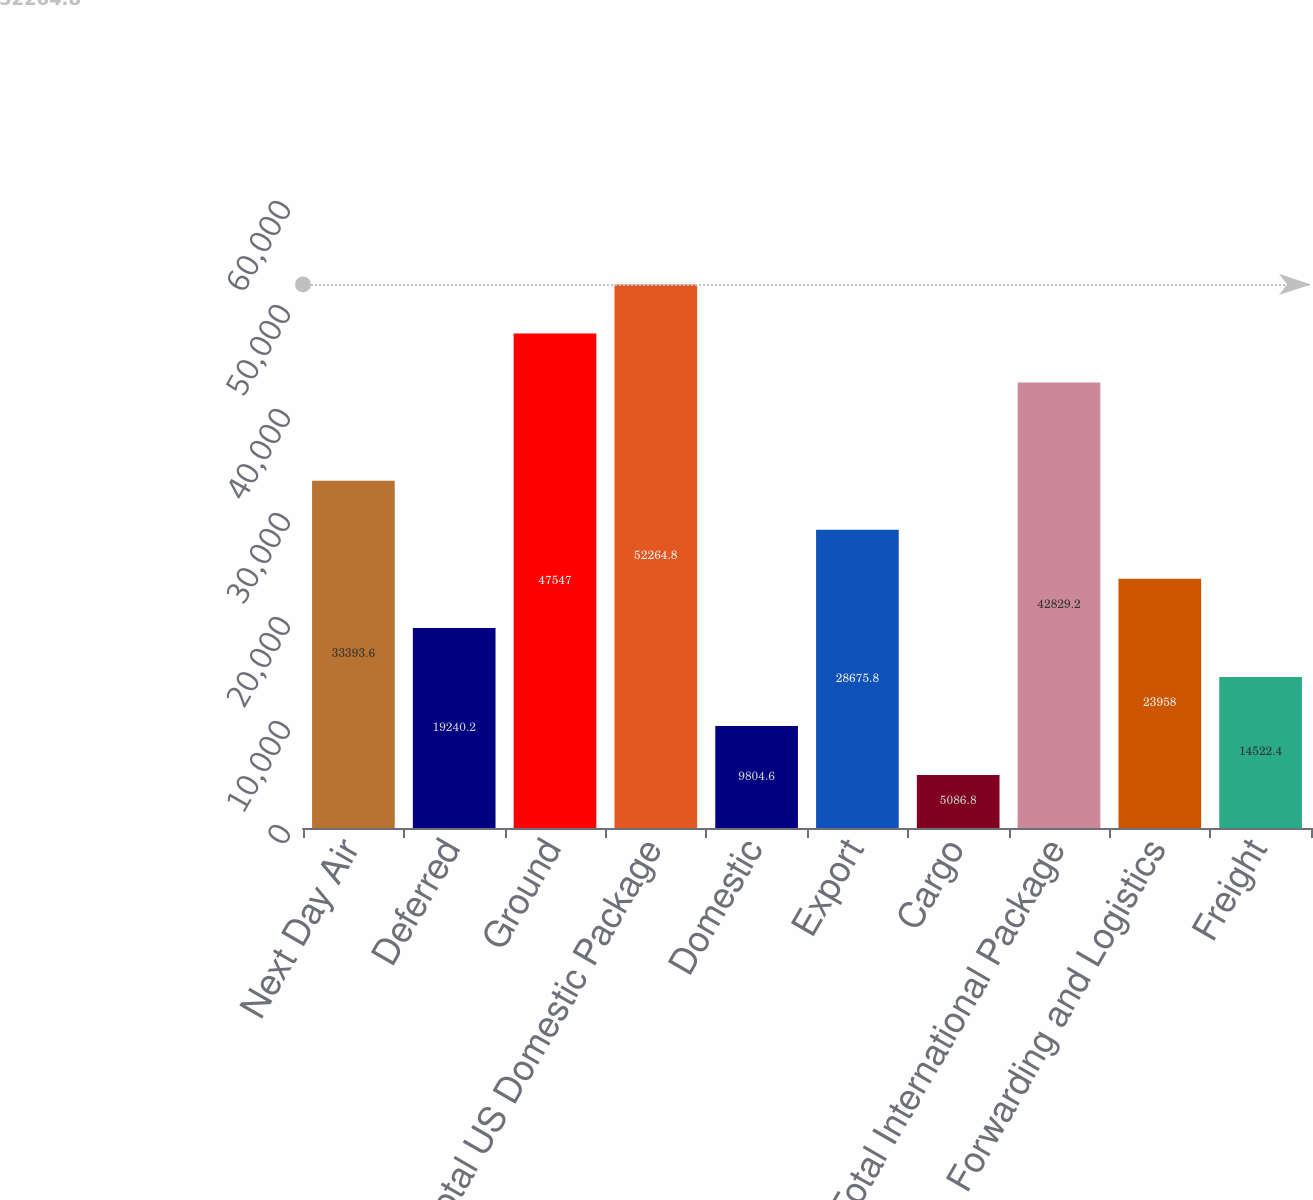Convert chart. <chart><loc_0><loc_0><loc_500><loc_500><bar_chart><fcel>Next Day Air<fcel>Deferred<fcel>Ground<fcel>Total US Domestic Package<fcel>Domestic<fcel>Export<fcel>Cargo<fcel>Total International Package<fcel>Forwarding and Logistics<fcel>Freight<nl><fcel>33393.6<fcel>19240.2<fcel>47547<fcel>52264.8<fcel>9804.6<fcel>28675.8<fcel>5086.8<fcel>42829.2<fcel>23958<fcel>14522.4<nl></chart> 